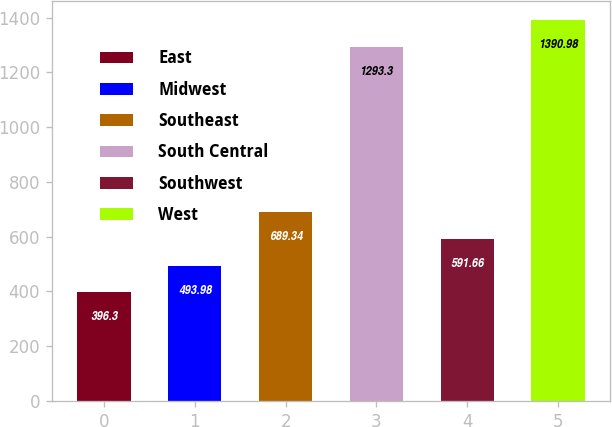Convert chart to OTSL. <chart><loc_0><loc_0><loc_500><loc_500><bar_chart><fcel>East<fcel>Midwest<fcel>Southeast<fcel>South Central<fcel>Southwest<fcel>West<nl><fcel>396.3<fcel>493.98<fcel>689.34<fcel>1293.3<fcel>591.66<fcel>1390.98<nl></chart> 